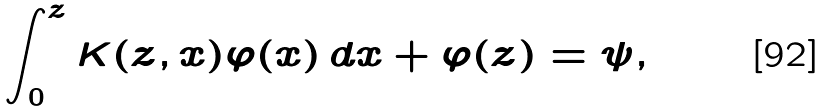<formula> <loc_0><loc_0><loc_500><loc_500>\int _ { 0 } ^ { z } K ( z , x ) \varphi ( x ) \, d x + \varphi ( z ) = \psi ,</formula> 